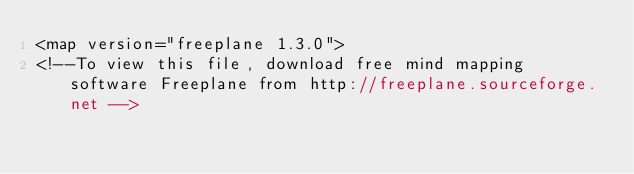Convert code to text. <code><loc_0><loc_0><loc_500><loc_500><_ObjectiveC_><map version="freeplane 1.3.0">
<!--To view this file, download free mind mapping software Freeplane from http://freeplane.sourceforge.net --></code> 